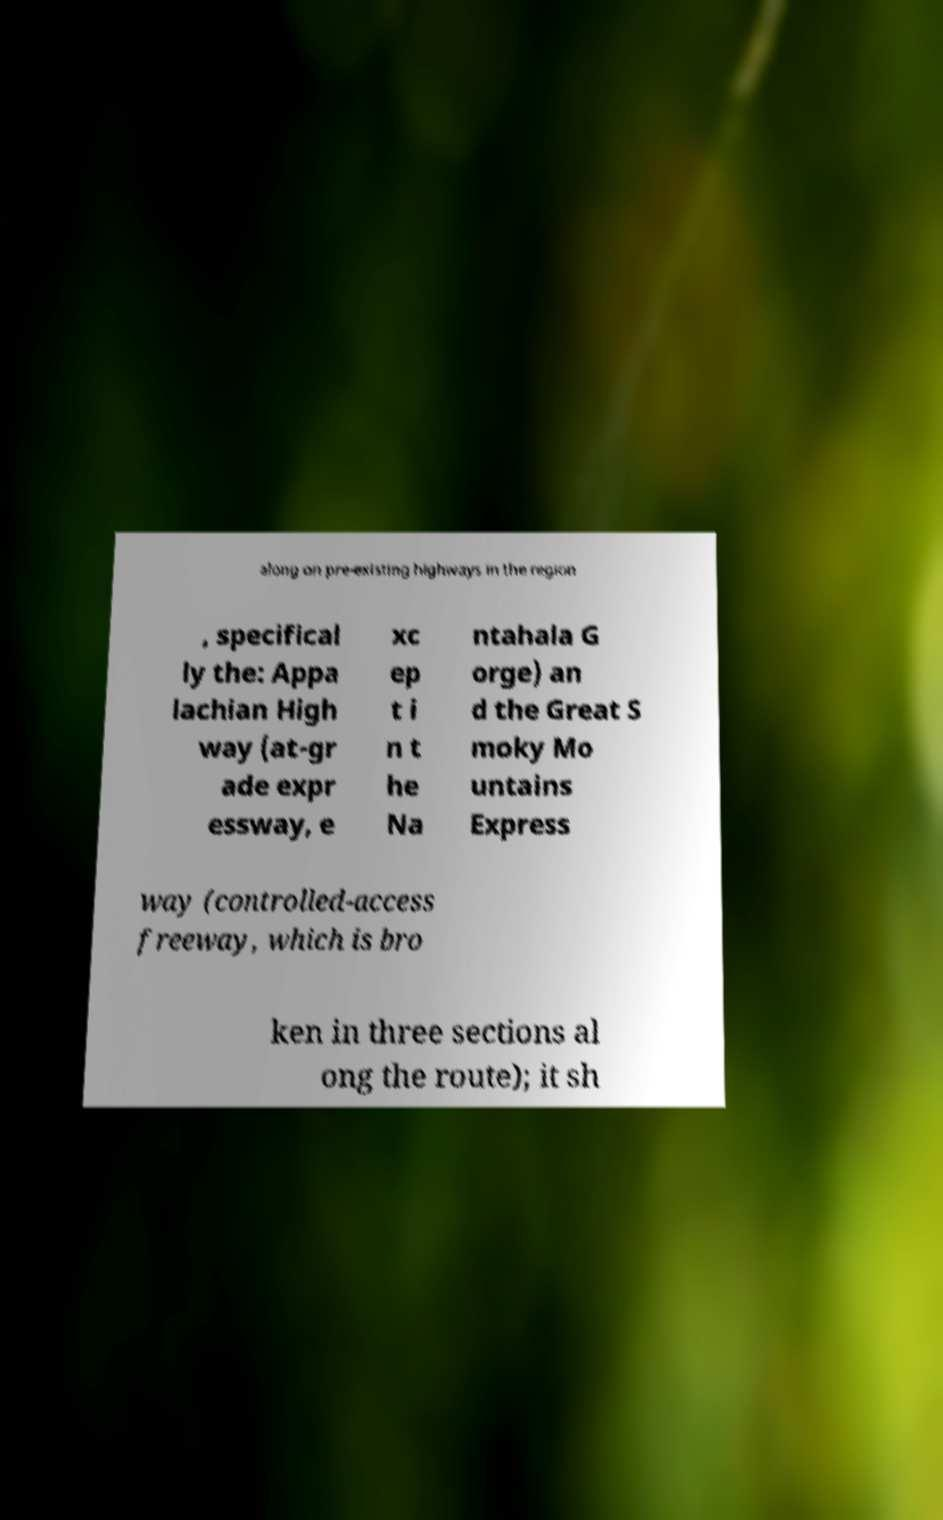For documentation purposes, I need the text within this image transcribed. Could you provide that? along on pre-existing highways in the region , specifical ly the: Appa lachian High way (at-gr ade expr essway, e xc ep t i n t he Na ntahala G orge) an d the Great S moky Mo untains Express way (controlled-access freeway, which is bro ken in three sections al ong the route); it sh 